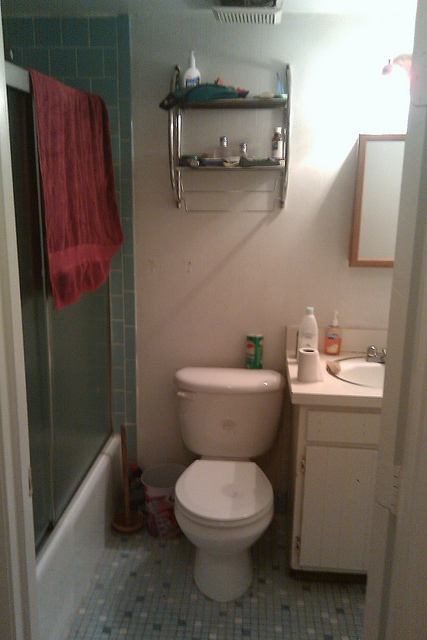What is in the container on the toilet tank?
A. toothpaste
B. bubble bath
C. cleanser
D. baby powder The container on the toilet tank appears to hold a substance commonly used for personal hygiene in a bathroom setting. While toothpaste is often found in bathrooms, the container's size and location suggest a product used for cleaning, making options such as bubble bath, cleanser, or baby powder more plausible. Considering the typical context and packaging, it seems reasonable to deduce it to be a cleanser, which is used to maintain a hygienic and sanitary environment. 